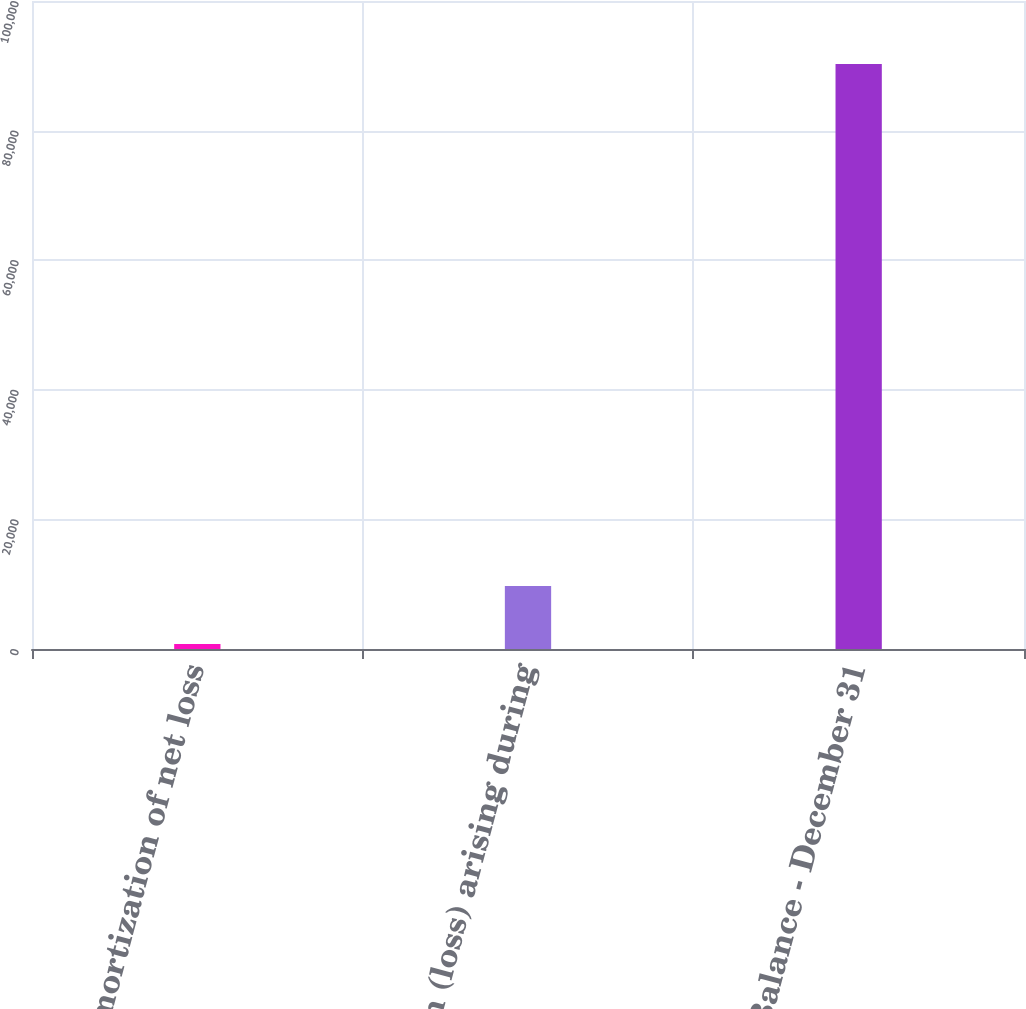Convert chart to OTSL. <chart><loc_0><loc_0><loc_500><loc_500><bar_chart><fcel>Amortization of net loss<fcel>Net gain (loss) arising during<fcel>Balance - December 31<nl><fcel>773<fcel>9722.7<fcel>90270<nl></chart> 